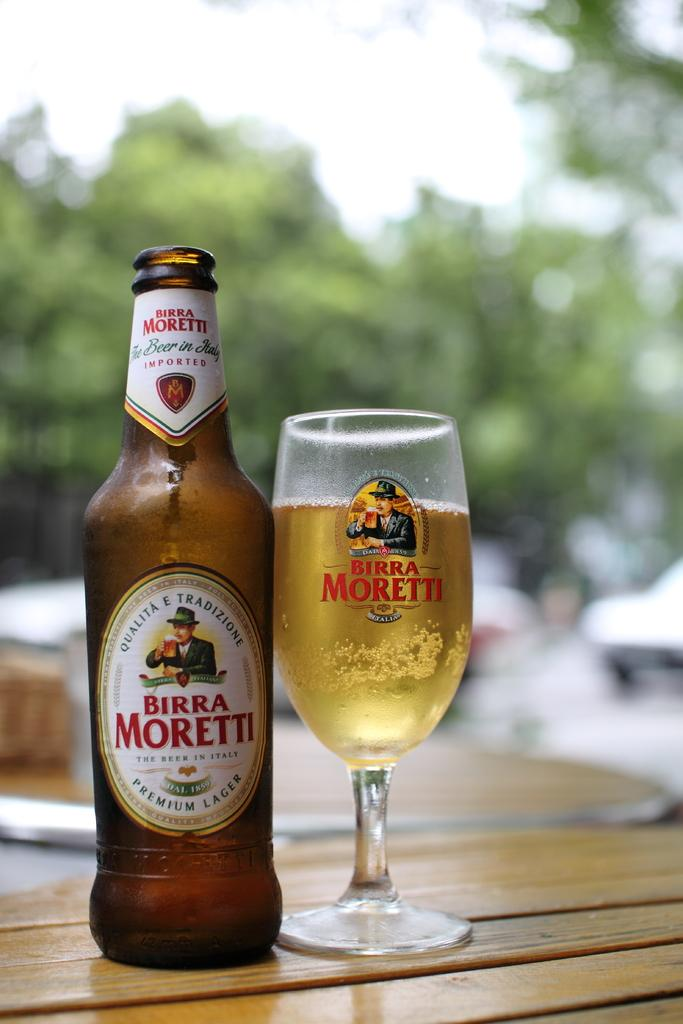Provide a one-sentence caption for the provided image. A bottle of beer and a glass with the name Birra Moretti on them both. 